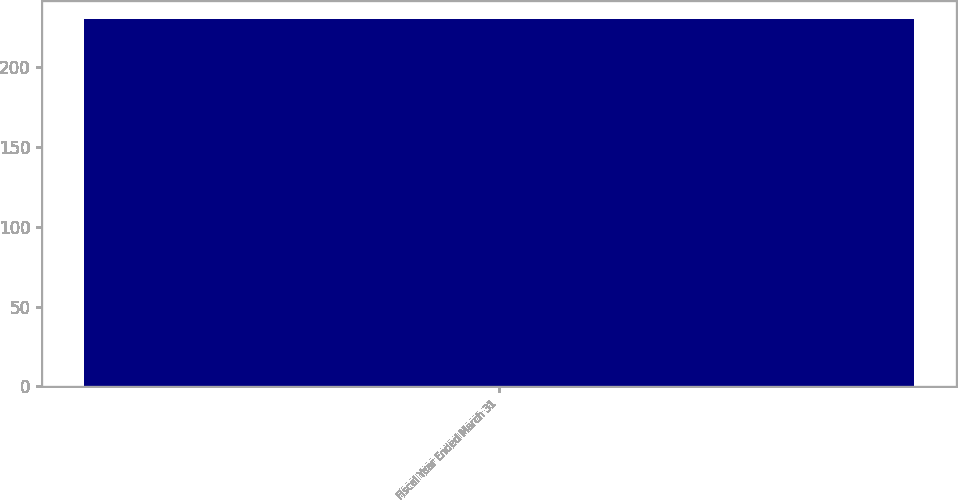<chart> <loc_0><loc_0><loc_500><loc_500><bar_chart><fcel>Fiscal Year Ended March 31<nl><fcel>230<nl></chart> 